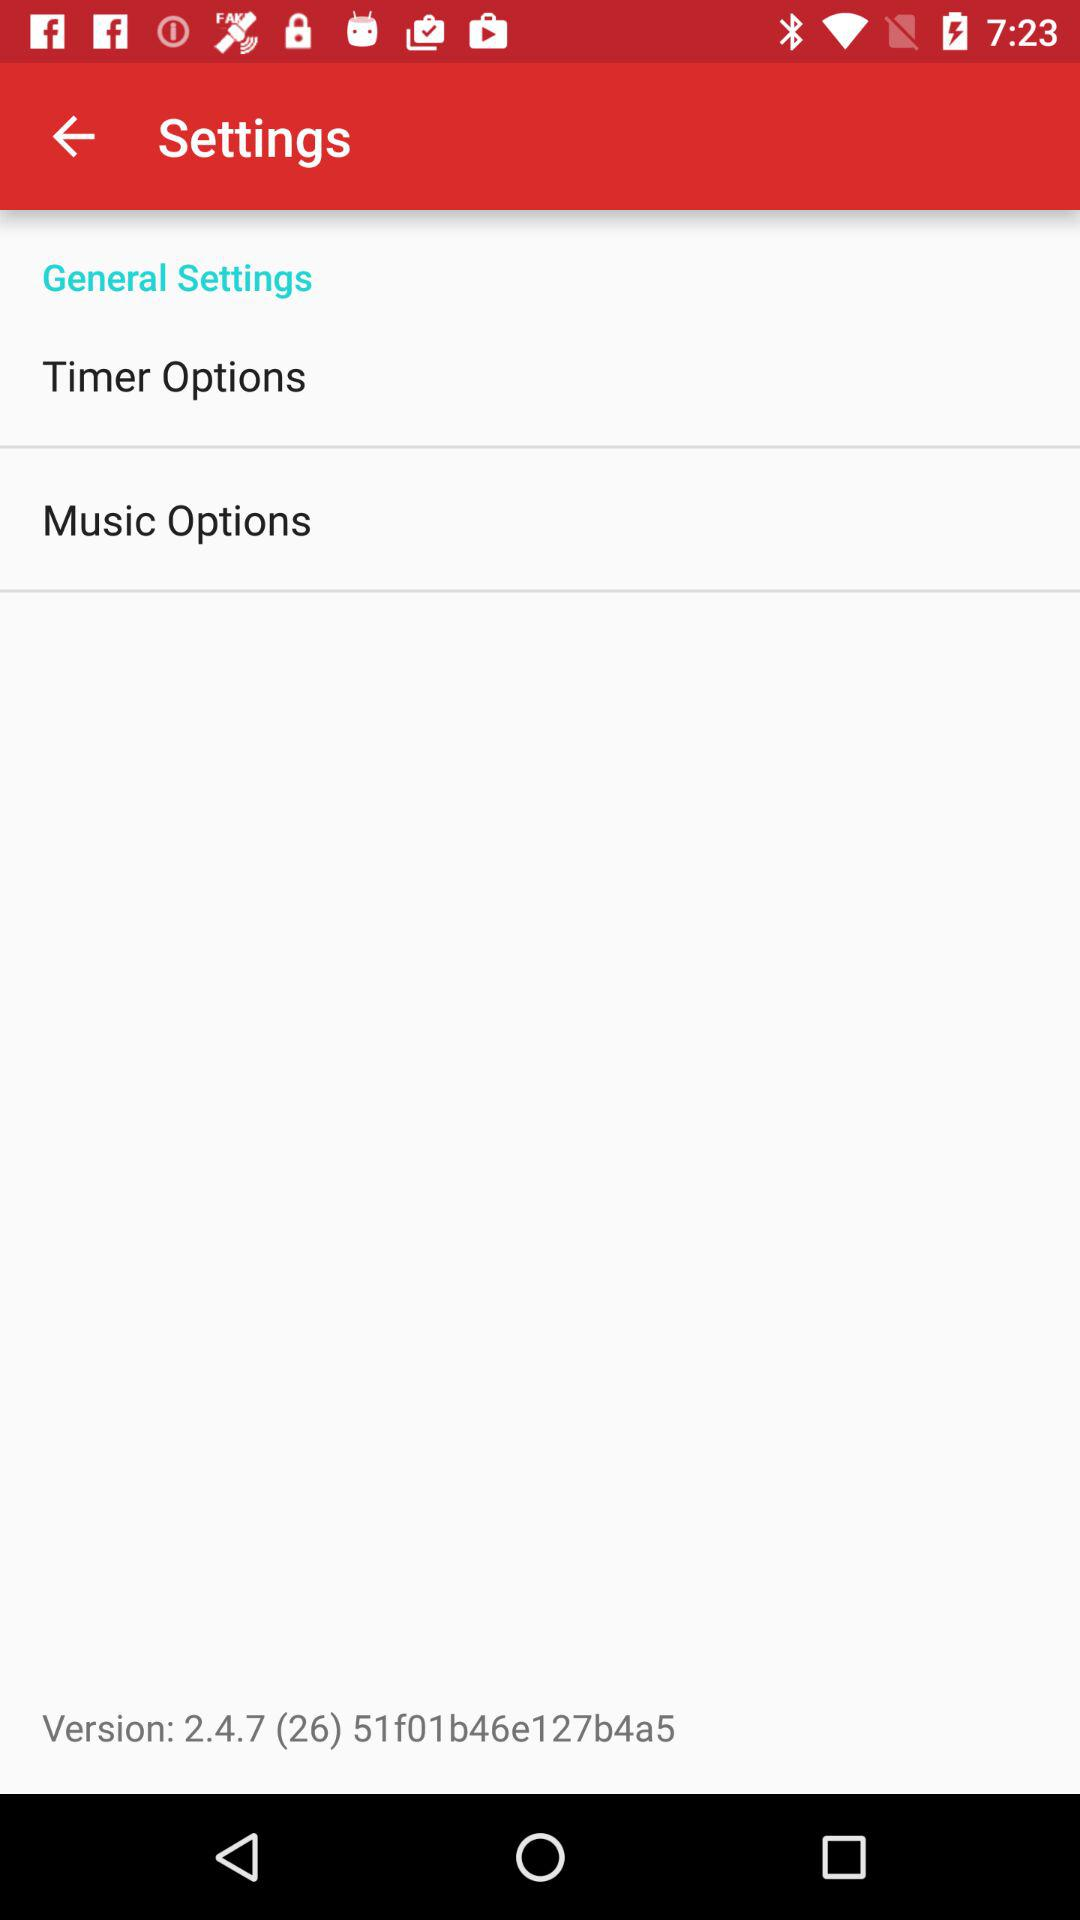What version is used? The version is 2.4.7 (26) 51f01b46e127b4a5. 